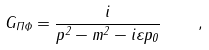Convert formula to latex. <formula><loc_0><loc_0><loc_500><loc_500>G _ { \Pi \Phi } = \frac { i } { p ^ { 2 } - m ^ { 2 } - i \varepsilon p _ { 0 } } \quad ,</formula> 